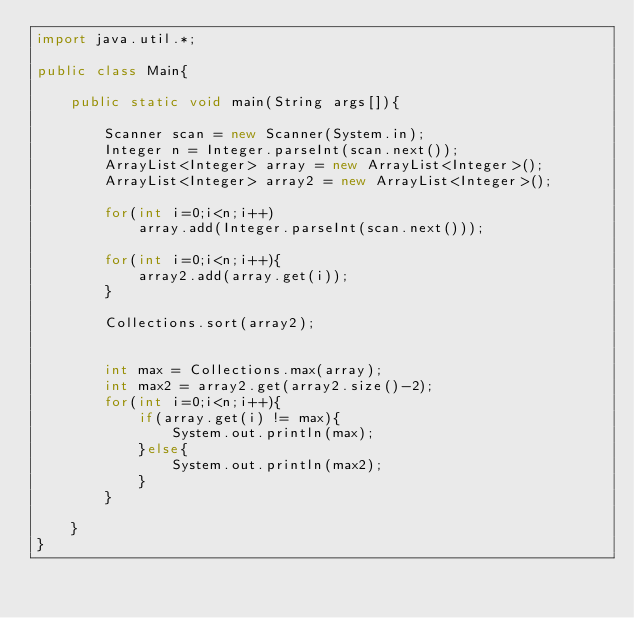<code> <loc_0><loc_0><loc_500><loc_500><_Java_>import java.util.*;

public class Main{

    public static void main(String args[]){

        Scanner scan = new Scanner(System.in);
        Integer n = Integer.parseInt(scan.next());
        ArrayList<Integer> array = new ArrayList<Integer>();
        ArrayList<Integer> array2 = new ArrayList<Integer>();

        for(int i=0;i<n;i++)   
            array.add(Integer.parseInt(scan.next()));

        for(int i=0;i<n;i++){
            array2.add(array.get(i));
        }

        Collections.sort(array2);


        int max = Collections.max(array);
        int max2 = array2.get(array2.size()-2);
        for(int i=0;i<n;i++){
            if(array.get(i) != max){
                System.out.println(max);
            }else{
                System.out.println(max2);
            }
        }

    }
}</code> 